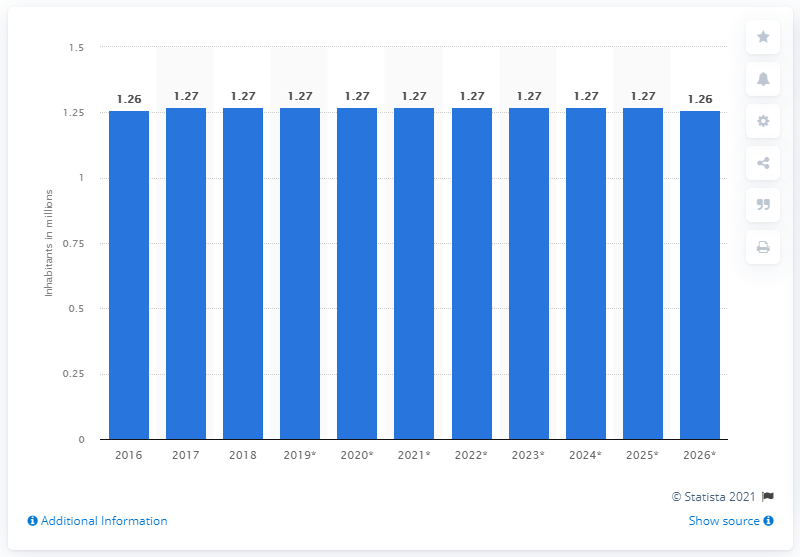Mention a couple of crucial points in this snapshot. As of 2018, the population of Mauritius was 1.26 million. 